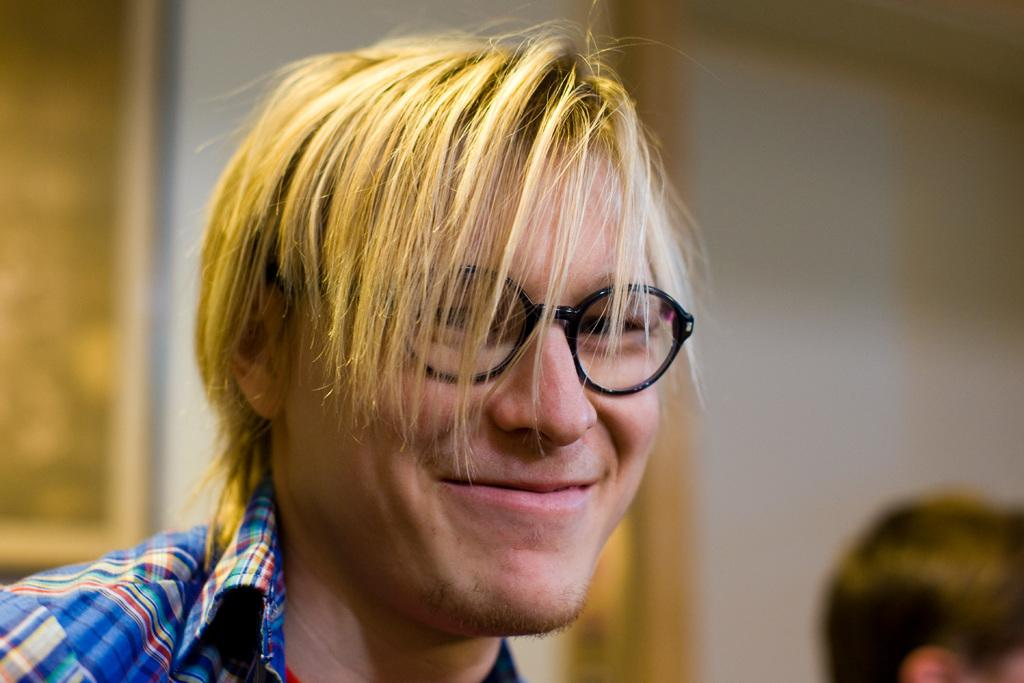What is the main subject of the image? There is a person in the image. What can be observed about the person's appearance? The person is wearing spectacles and has short hair. What type of lawyer is the person in the image? There is no indication in the image that the person is a lawyer, so it cannot be determined from the picture. 